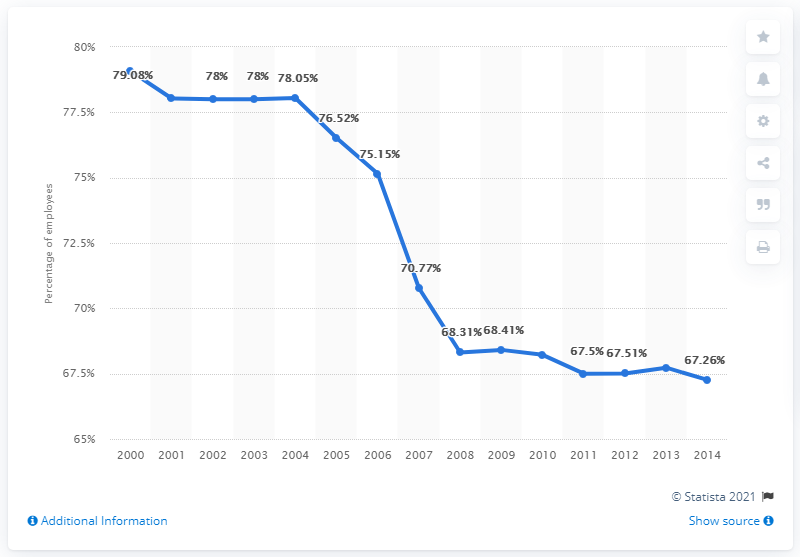Give some essential details in this illustration. In 2007, there was a significant decline in data values, making that year the one with the steepest drop. The maximum percent across all years is 1.08 if the mode employees percentage is deducted from it. 